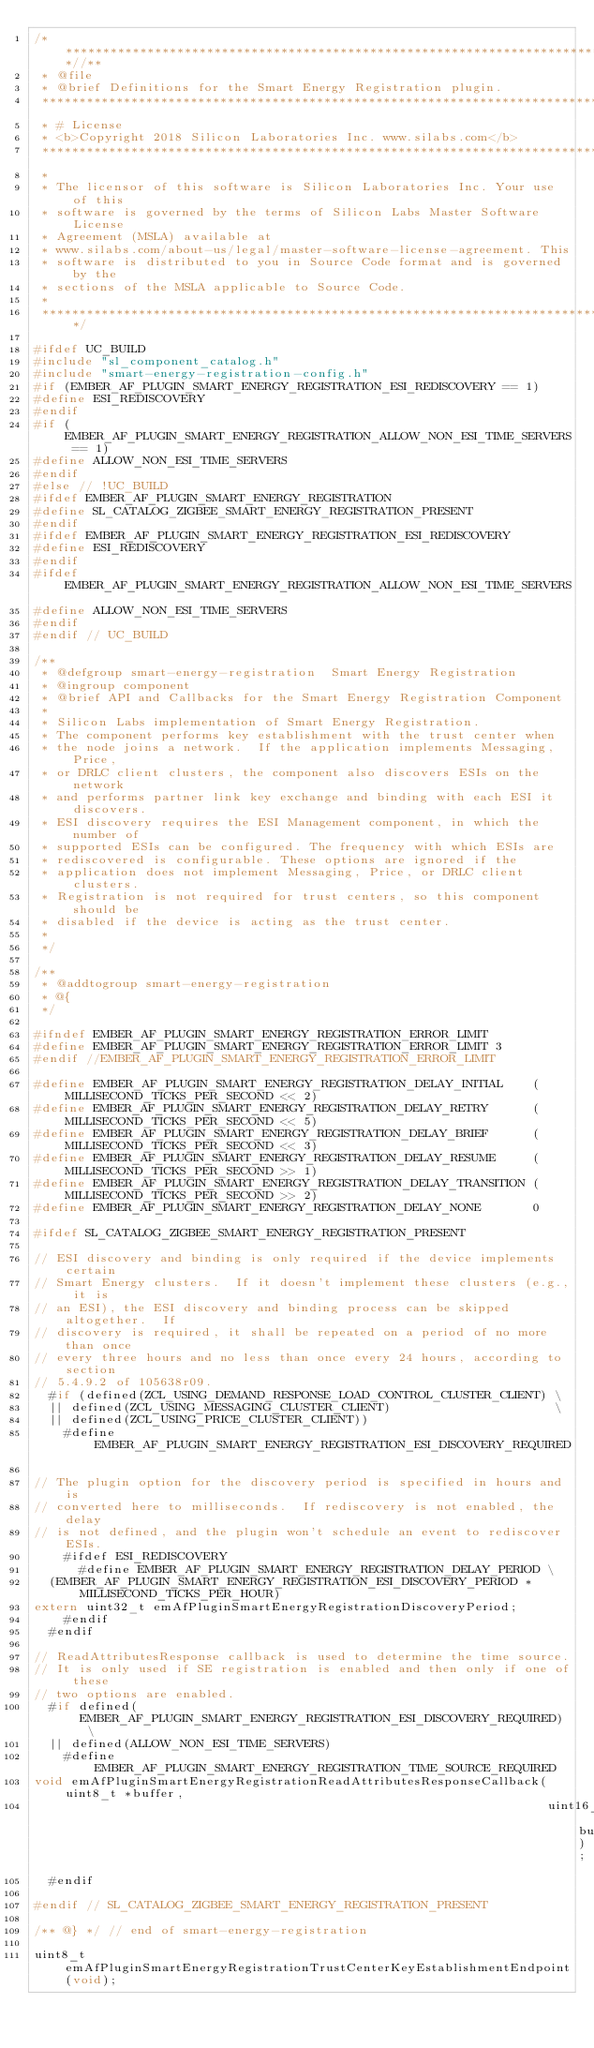<code> <loc_0><loc_0><loc_500><loc_500><_C_>/***************************************************************************//**
 * @file
 * @brief Definitions for the Smart Energy Registration plugin.
 *******************************************************************************
 * # License
 * <b>Copyright 2018 Silicon Laboratories Inc. www.silabs.com</b>
 *******************************************************************************
 *
 * The licensor of this software is Silicon Laboratories Inc. Your use of this
 * software is governed by the terms of Silicon Labs Master Software License
 * Agreement (MSLA) available at
 * www.silabs.com/about-us/legal/master-software-license-agreement. This
 * software is distributed to you in Source Code format and is governed by the
 * sections of the MSLA applicable to Source Code.
 *
 ******************************************************************************/

#ifdef UC_BUILD
#include "sl_component_catalog.h"
#include "smart-energy-registration-config.h"
#if (EMBER_AF_PLUGIN_SMART_ENERGY_REGISTRATION_ESI_REDISCOVERY == 1)
#define ESI_REDISCOVERY
#endif
#if (EMBER_AF_PLUGIN_SMART_ENERGY_REGISTRATION_ALLOW_NON_ESI_TIME_SERVERS == 1)
#define ALLOW_NON_ESI_TIME_SERVERS
#endif
#else // !UC_BUILD
#ifdef EMBER_AF_PLUGIN_SMART_ENERGY_REGISTRATION
#define SL_CATALOG_ZIGBEE_SMART_ENERGY_REGISTRATION_PRESENT
#endif
#ifdef EMBER_AF_PLUGIN_SMART_ENERGY_REGISTRATION_ESI_REDISCOVERY
#define ESI_REDISCOVERY
#endif
#ifdef EMBER_AF_PLUGIN_SMART_ENERGY_REGISTRATION_ALLOW_NON_ESI_TIME_SERVERS
#define ALLOW_NON_ESI_TIME_SERVERS
#endif
#endif // UC_BUILD

/**
 * @defgroup smart-energy-registration  Smart Energy Registration
 * @ingroup component
 * @brief API and Callbacks for the Smart Energy Registration Component
 *
 * Silicon Labs implementation of Smart Energy Registration.
 * The component performs key establishment with the trust center when
 * the node joins a network.  If the application implements Messaging, Price,
 * or DRLC client clusters, the component also discovers ESIs on the network
 * and performs partner link key exchange and binding with each ESI it discovers.
 * ESI discovery requires the ESI Management component, in which the number of
 * supported ESIs can be configured. The frequency with which ESIs are
 * rediscovered is configurable. These options are ignored if the
 * application does not implement Messaging, Price, or DRLC client clusters.
 * Registration is not required for trust centers, so this component should be
 * disabled if the device is acting as the trust center.
 *
 */

/**
 * @addtogroup smart-energy-registration
 * @{
 */

#ifndef EMBER_AF_PLUGIN_SMART_ENERGY_REGISTRATION_ERROR_LIMIT
#define EMBER_AF_PLUGIN_SMART_ENERGY_REGISTRATION_ERROR_LIMIT 3
#endif //EMBER_AF_PLUGIN_SMART_ENERGY_REGISTRATION_ERROR_LIMIT

#define EMBER_AF_PLUGIN_SMART_ENERGY_REGISTRATION_DELAY_INITIAL    (MILLISECOND_TICKS_PER_SECOND << 2)
#define EMBER_AF_PLUGIN_SMART_ENERGY_REGISTRATION_DELAY_RETRY      (MILLISECOND_TICKS_PER_SECOND << 5)
#define EMBER_AF_PLUGIN_SMART_ENERGY_REGISTRATION_DELAY_BRIEF      (MILLISECOND_TICKS_PER_SECOND << 3)
#define EMBER_AF_PLUGIN_SMART_ENERGY_REGISTRATION_DELAY_RESUME     (MILLISECOND_TICKS_PER_SECOND >> 1)
#define EMBER_AF_PLUGIN_SMART_ENERGY_REGISTRATION_DELAY_TRANSITION (MILLISECOND_TICKS_PER_SECOND >> 2)
#define EMBER_AF_PLUGIN_SMART_ENERGY_REGISTRATION_DELAY_NONE       0

#ifdef SL_CATALOG_ZIGBEE_SMART_ENERGY_REGISTRATION_PRESENT

// ESI discovery and binding is only required if the device implements certain
// Smart Energy clusters.  If it doesn't implement these clusters (e.g., it is
// an ESI), the ESI discovery and binding process can be skipped altogether.  If
// discovery is required, it shall be repeated on a period of no more than once
// every three hours and no less than once every 24 hours, according to section
// 5.4.9.2 of 105638r09.
  #if (defined(ZCL_USING_DEMAND_RESPONSE_LOAD_CONTROL_CLUSTER_CLIENT) \
  || defined(ZCL_USING_MESSAGING_CLUSTER_CLIENT)                      \
  || defined(ZCL_USING_PRICE_CLUSTER_CLIENT))
    #define EMBER_AF_PLUGIN_SMART_ENERGY_REGISTRATION_ESI_DISCOVERY_REQUIRED

// The plugin option for the discovery period is specified in hours and is
// converted here to milliseconds.  If rediscovery is not enabled, the delay
// is not defined, and the plugin won't schedule an event to rediscover ESIs.
    #ifdef ESI_REDISCOVERY
      #define EMBER_AF_PLUGIN_SMART_ENERGY_REGISTRATION_DELAY_PERIOD \
  (EMBER_AF_PLUGIN_SMART_ENERGY_REGISTRATION_ESI_DISCOVERY_PERIOD * MILLISECOND_TICKS_PER_HOUR)
extern uint32_t emAfPluginSmartEnergyRegistrationDiscoveryPeriod;
    #endif
  #endif

// ReadAttributesResponse callback is used to determine the time source.
// It is only used if SE registration is enabled and then only if one of these
// two options are enabled.
  #if defined(EMBER_AF_PLUGIN_SMART_ENERGY_REGISTRATION_ESI_DISCOVERY_REQUIRED) \
  || defined(ALLOW_NON_ESI_TIME_SERVERS)
    #define EMBER_AF_PLUGIN_SMART_ENERGY_REGISTRATION_TIME_SOURCE_REQUIRED
void emAfPluginSmartEnergyRegistrationReadAttributesResponseCallback(uint8_t *buffer,
                                                                     uint16_t bufLen);
  #endif

#endif // SL_CATALOG_ZIGBEE_SMART_ENERGY_REGISTRATION_PRESENT

/** @} */ // end of smart-energy-registration

uint8_t emAfPluginSmartEnergyRegistrationTrustCenterKeyEstablishmentEndpoint(void);
</code> 